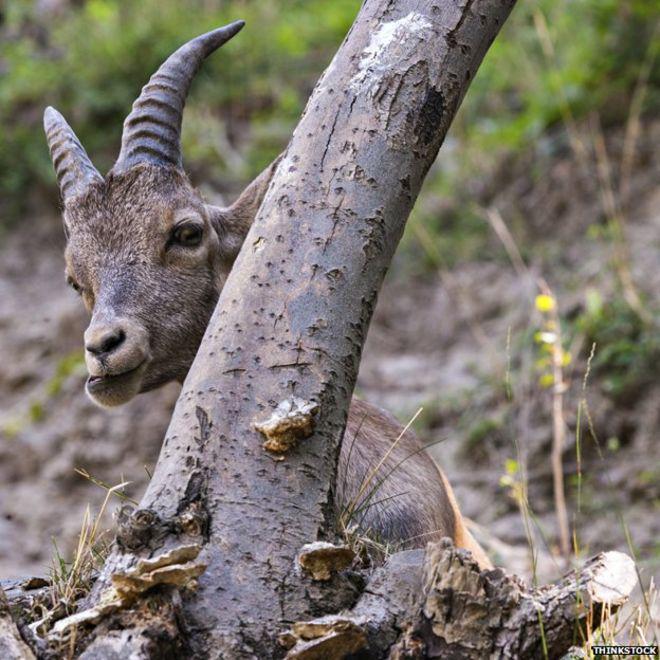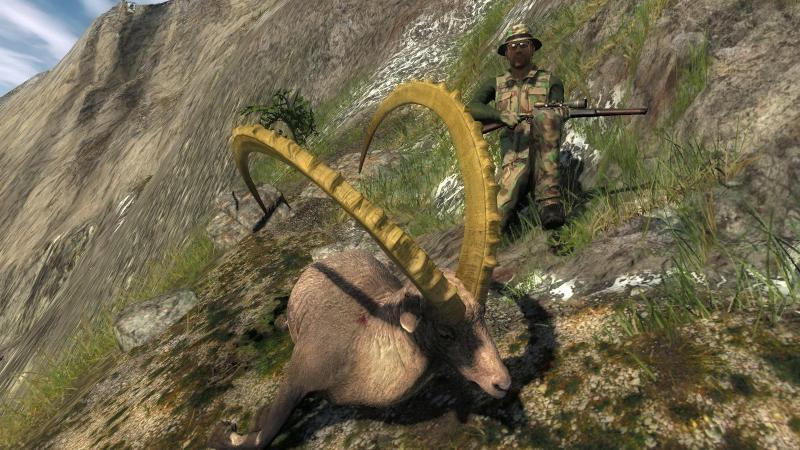The first image is the image on the left, the second image is the image on the right. For the images shown, is this caption "An image shows one camera-facing long-horned animal with an upright head, with mountain peaks in the background." true? Answer yes or no. No. The first image is the image on the left, the second image is the image on the right. Given the left and right images, does the statement "A horned animal is posed with a view of the mountains behind it." hold true? Answer yes or no. No. 